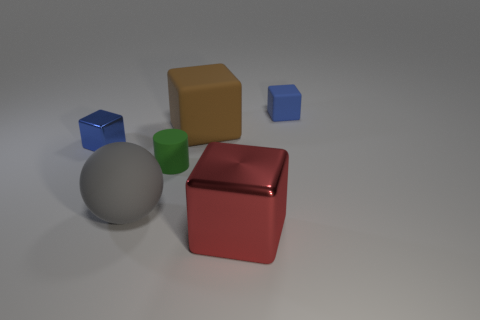Can you describe the size and color of the objects in the middle of the image? In the center of the image, there is a large beige cube and a glossy red cube, distinguished by their bold colors and size, overshadowing the smaller blue cube and green cylinder. The beige cube has a matte finish, whereas the red cube features a reflective surface, adding a touch of contrast to the scene. 